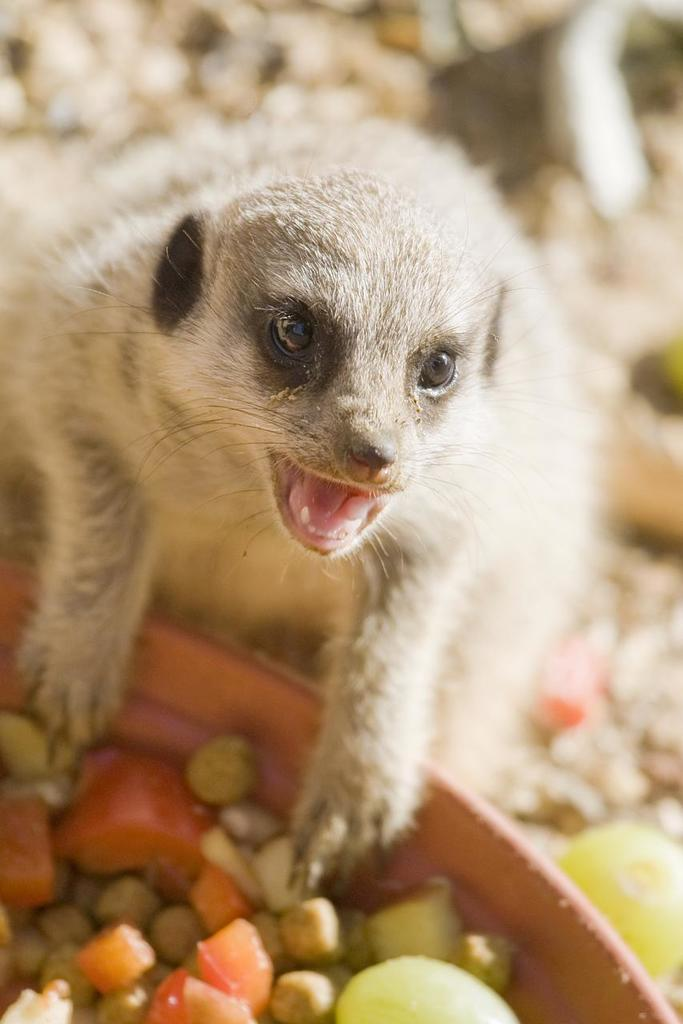What is the main subject of the image? There is an animal sitting on the ground in the image. What else can be seen in the image besides the animal? There are fruits cut into pieces in the image, which are kept in a bowl. Can you describe the background of the image? The background of the image is blurred. What type of bells can be heard ringing in the image? There are no bells present in the image, and therefore no sound can be heard. 